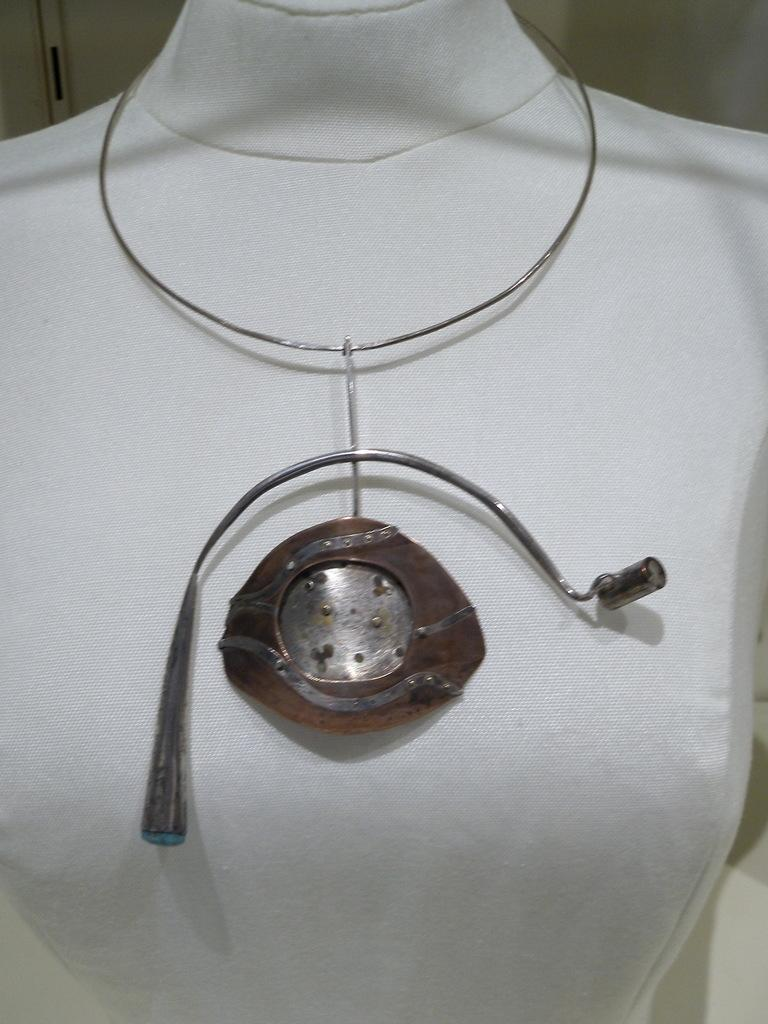What type of person is wearing equipment in the image? There is a metal type wearing equipment in the image. What other object can be seen in the image? There is a mannequin in the image. What color is the clothing worn by the mannequin? The mannequin is wearing white clothing. What type of clover is growing near the metal type in the image? There is no clover present in the image. What selection of items is available for purchase in the image? The image does not depict a selection of items for purchase. 